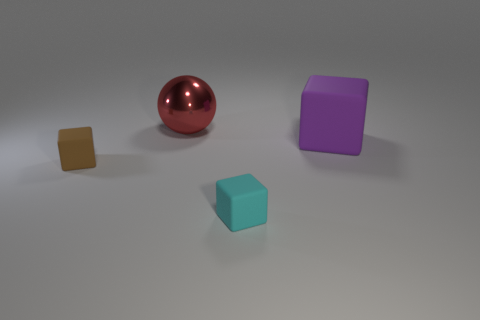What number of other objects are the same shape as the large purple rubber object?
Ensure brevity in your answer.  2. What is the shape of the thing that is on the left side of the ball?
Your answer should be compact. Cube. Is there a cyan object that is in front of the matte cube that is behind the brown thing?
Ensure brevity in your answer.  Yes. What is the color of the thing that is behind the small brown rubber cube and left of the cyan rubber thing?
Your response must be concise. Red. Is there a rubber cube on the left side of the large thing that is behind the purple rubber block that is on the right side of the ball?
Ensure brevity in your answer.  Yes. What is the size of the cyan matte thing that is the same shape as the brown thing?
Provide a short and direct response. Small. Is there anything else that has the same material as the purple thing?
Make the answer very short. Yes. Are any tiny brown rubber cubes visible?
Make the answer very short. Yes. There is a big matte thing; does it have the same color as the tiny matte block that is behind the tiny cyan rubber object?
Your answer should be compact. No. There is a thing left of the big object that is behind the large thing that is on the right side of the cyan block; how big is it?
Your answer should be compact. Small. 